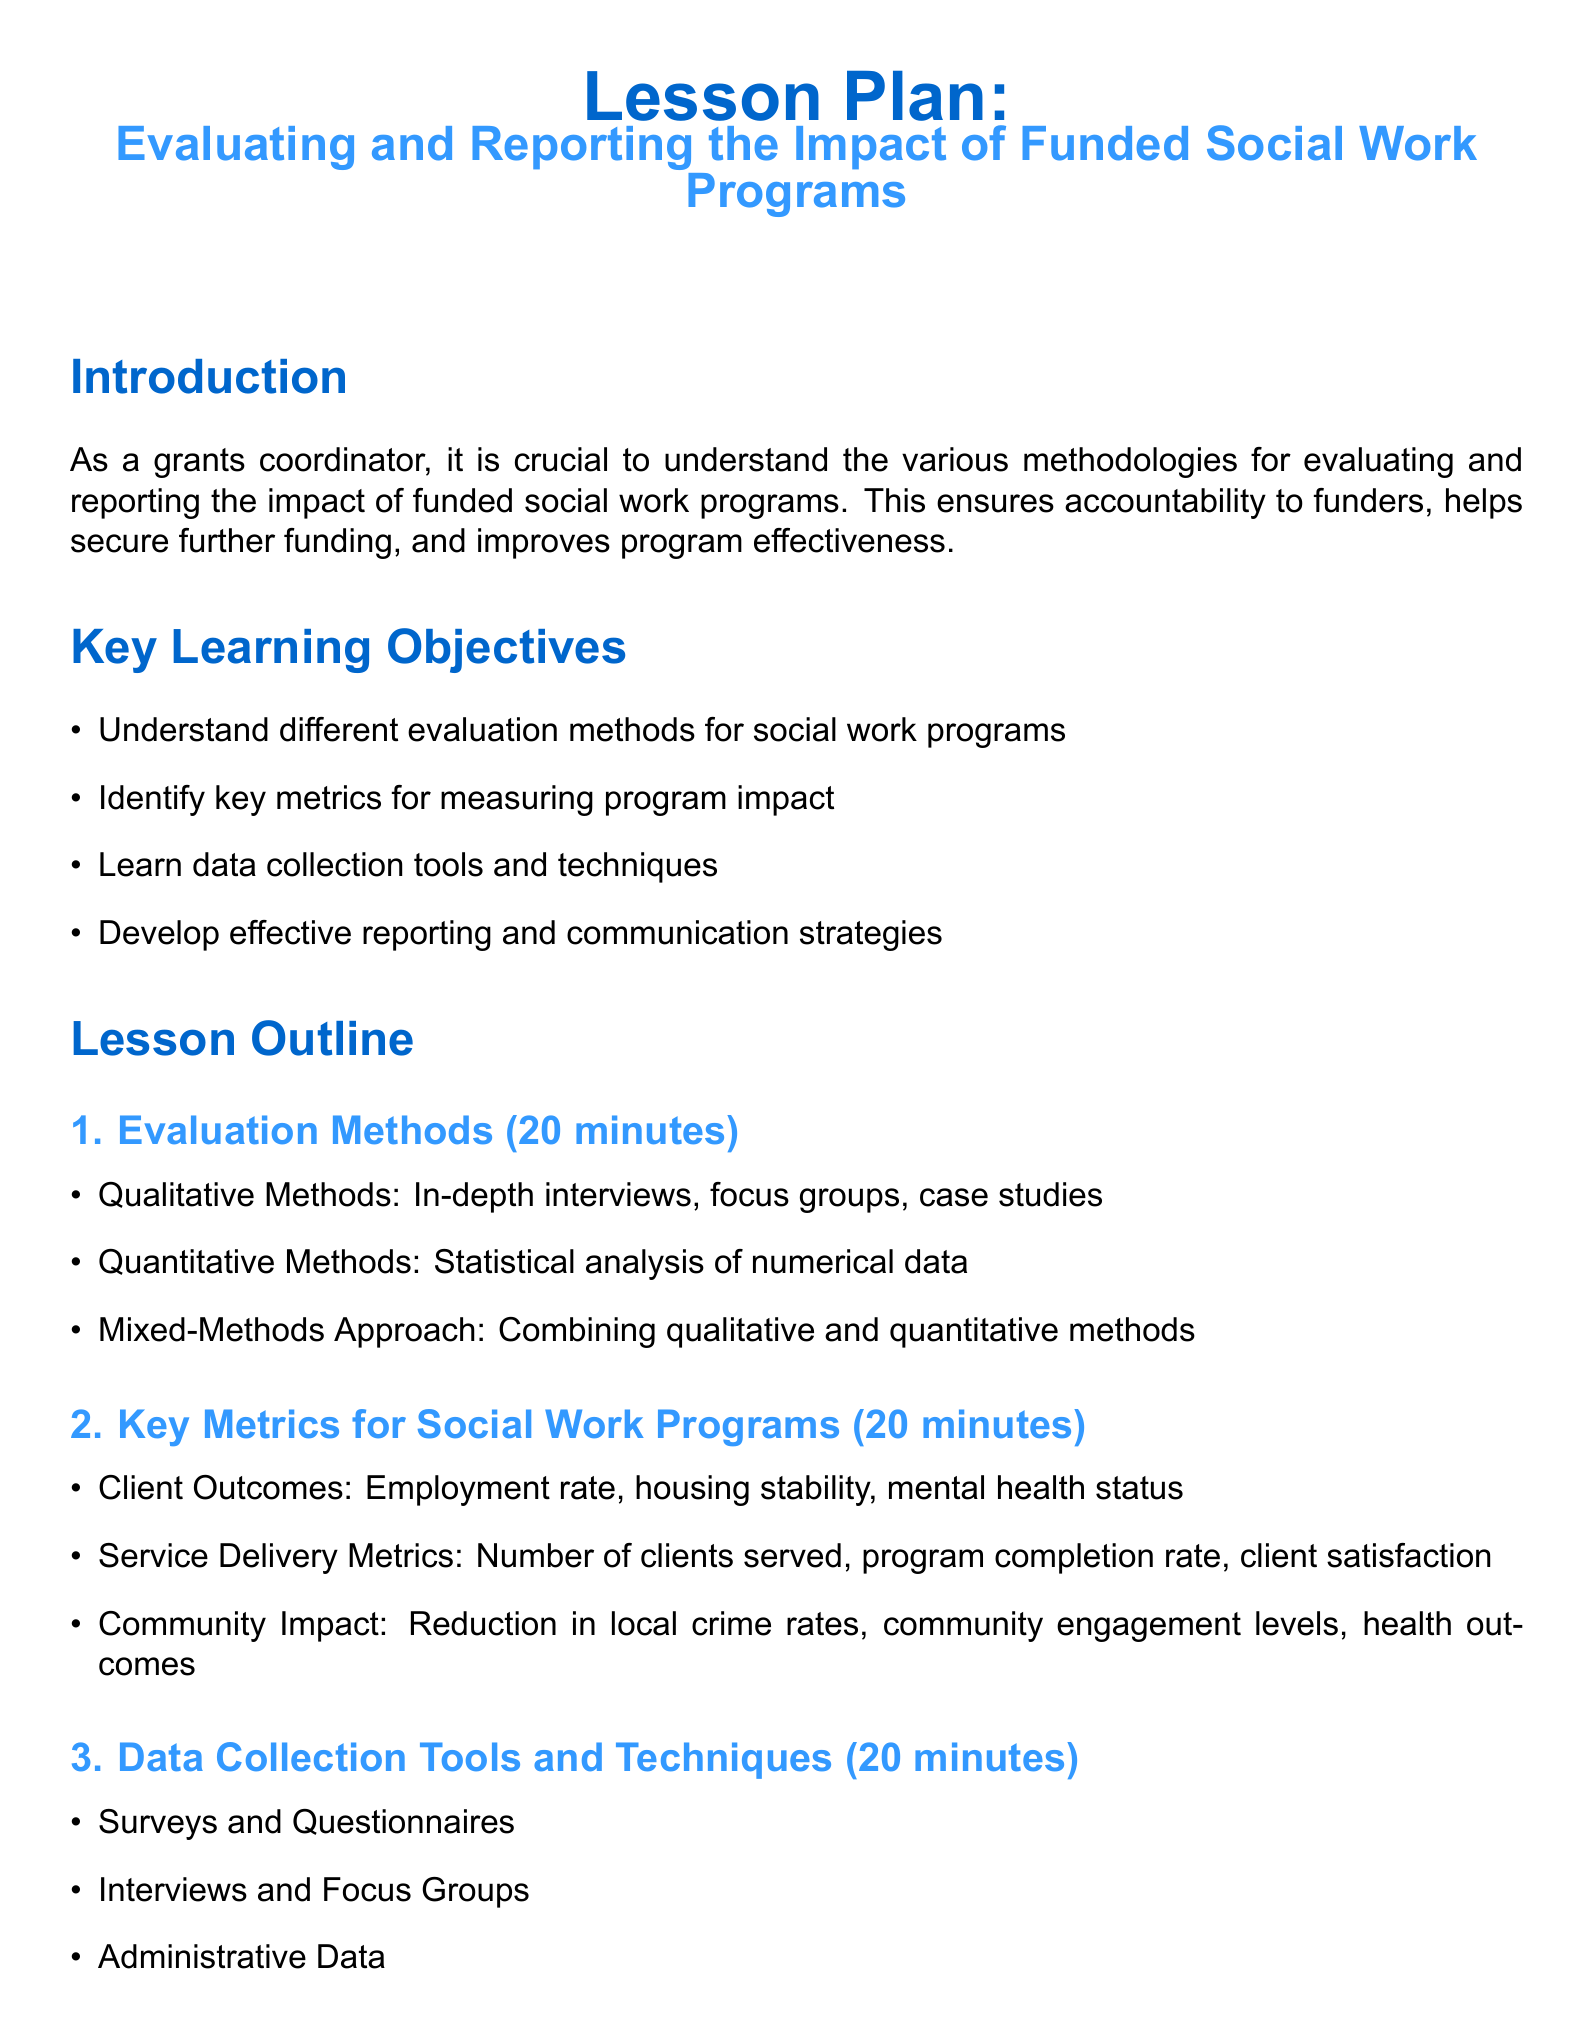what is the title of the lesson plan? The title is clearly stated at the beginning of the document.
Answer: Evaluating and Reporting the Impact of Funded Social Work Programs how long is the group exercise activity? The duration of the group exercise activity is mentioned directly in the document.
Answer: 20 minutes what are the key metrics for measuring program impact? The section on key metrics lists several specific metrics.
Answer: Client Outcomes, Service Delivery Metrics, Community Impact what data collection tool involves asking participants questions directly? The document mentions a specific data collection tool that involves direct questioning.
Answer: Interviews what is the main purpose of evaluation methods? Understanding the purpose of the evaluation methods can be inferred from the introduction of the document.
Answer: Accountability how many total sections are in the lesson outline? Counting the sections listed in the lesson outline provides this information.
Answer: 4 what type of reports are included in the reporting strategies? The types of reports are specifically mentioned under the reporting and communication strategies.
Answer: Stakeholder Reports what is the duration of the quiz? The duration of the quiz is explicitly indicated in the document.
Answer: 10 minutes which evaluation method combines qualitative and quantitative data? The document refers to a specific method that combines these approaches.
Answer: Mixed-Methods Approach 